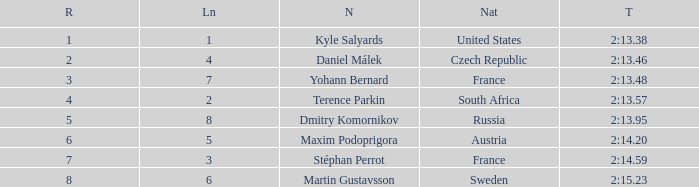What was Maxim Podoprigora's lowest rank? 6.0. 